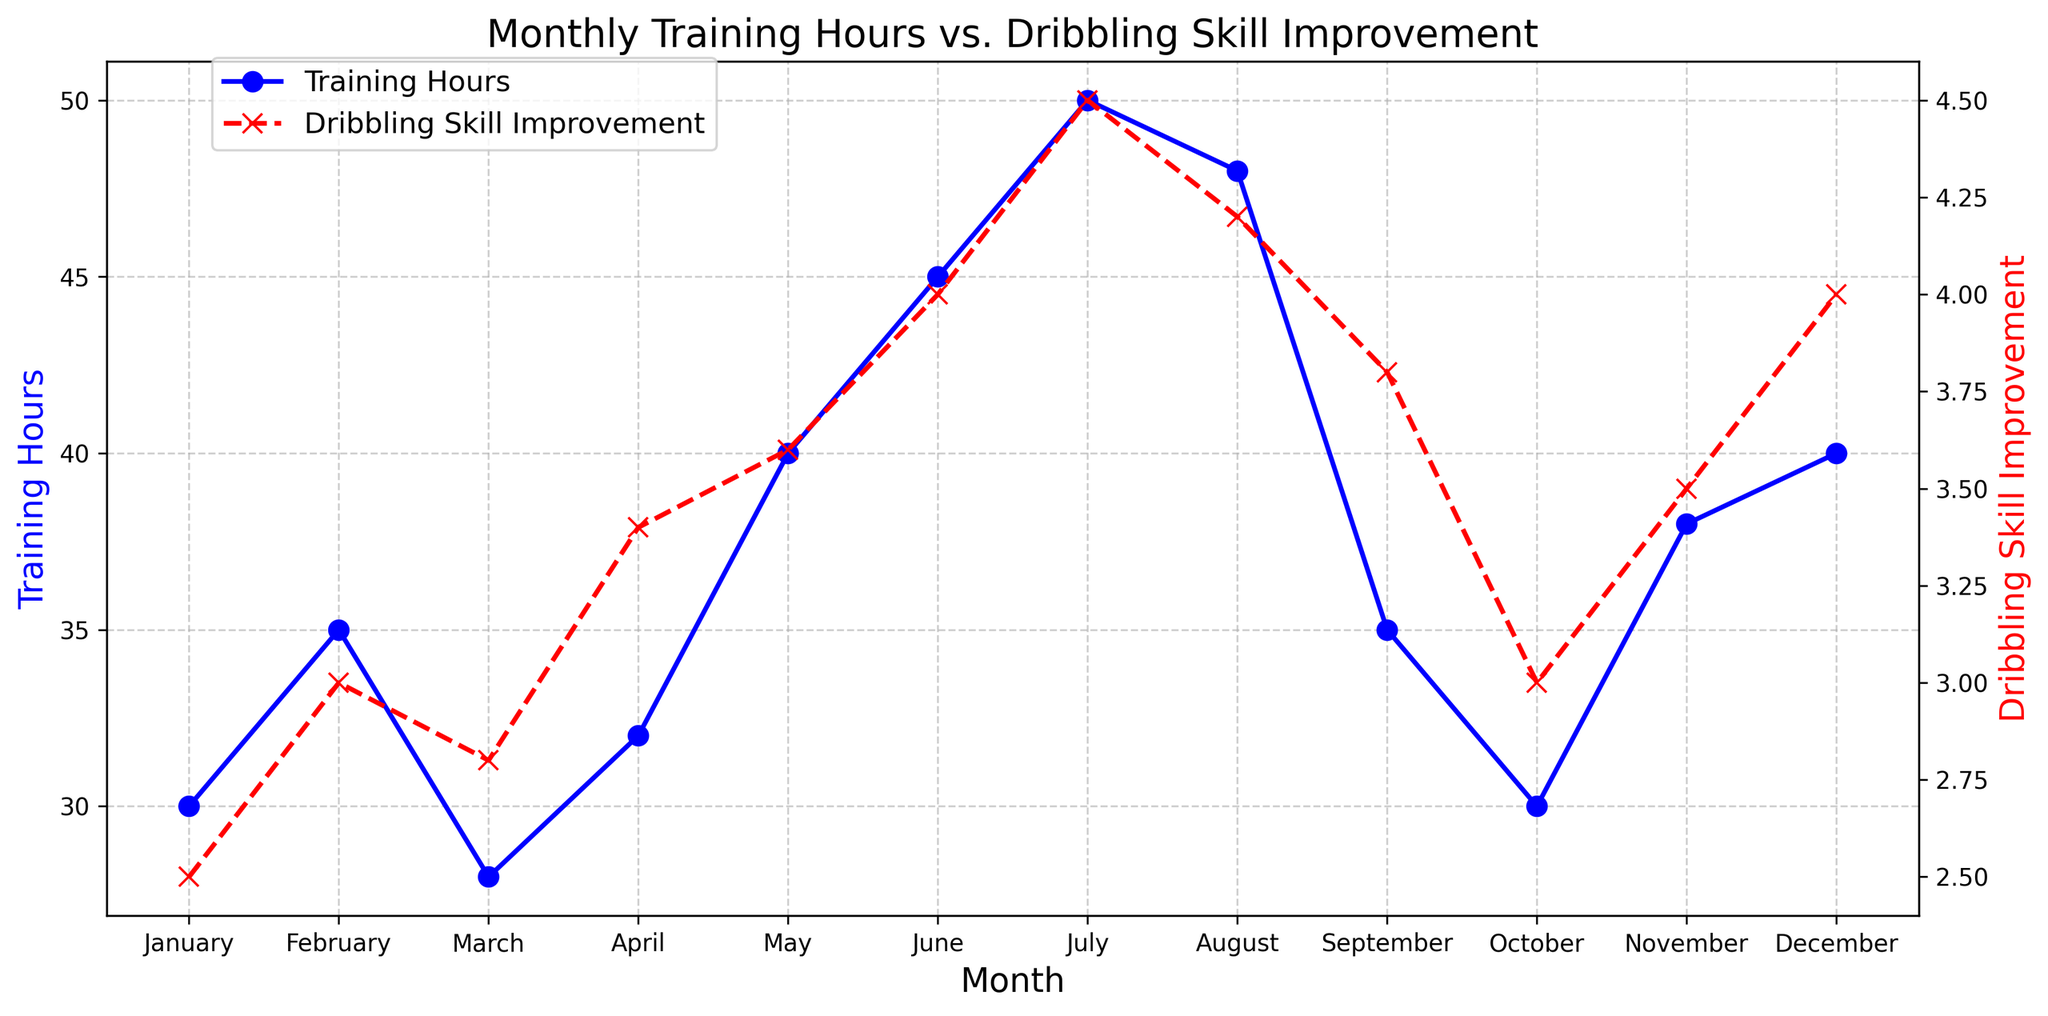What month has the highest training hours? According to the plot, the month with the highest training hours is identified by the tallest blue line. July has the blue line at its highest value.
Answer: July What is the difference in dribbling skill improvement between June and October? From the plot, June has a dribbling skill improvement of 4.0, while October has 3.0. Subtracting these values (4.0 - 3.0) gives the difference.
Answer: 1.0 Which months have equal training hours? By comparing the height of the blue lines on the plot, we can see that both May and December have the same height, indicating equal training hours of 40.
Answer: May and December What is the overall trend in dribbling skill improvement from January to December? Observing the red line with markers, it generally shows an increasing trend from January (2.5) to December (4.0), with slight fluctuations.
Answer: Increasing How many months have more than 40 training hours? Checking the height of the blue lines across months, both June (45) and July (50) exceed 40 training hours.
Answer: 2 Compare dribbling skill improvement in February and March. Which is higher? Looking at the red lines, February has a value of 3.0, while March has 2.8. Hence, February's dribbling skill improvement is higher.
Answer: February What is the average dribbling skill improvement for the entire year? Summing the skill improvements (2.5 + 3.0 + 2.8 + 3.4 + 3.6 + 4.0 + 4.5 + 4.2 + 3.8 + 3.0 + 3.5 + 4.0) and dividing by 12 gives (42.3 / 12).
Answer: 3.525 Which month shows the greatest improvement in dribbling skills relative to the previous month? By comparing the differences between consecutive months' skill improvements, March to April shows the largest change (3.4 - 2.8 = 0.6).
Answer: April How does the training hours’ pattern in September compare to October? The blue line for September is higher than October, indicating September has more training hours (35 vs. 30).
Answer: September In which month did more training hours result in the least improvement in dribbling skills? February (35 training hours, 3.0 improvement) and October (30 training hours, 3.0 improvement) show high hours without proportionate improvement. Out of these, February has the highest training hours, yet the same improvement.
Answer: February 